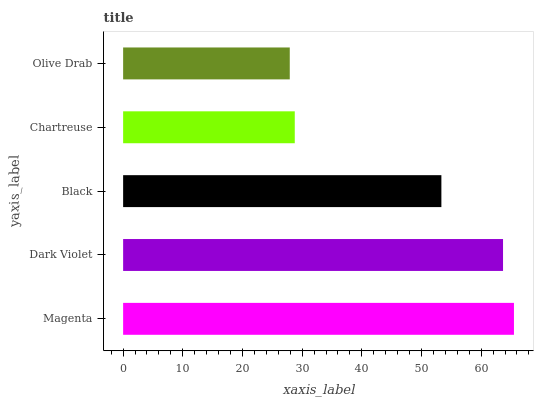Is Olive Drab the minimum?
Answer yes or no. Yes. Is Magenta the maximum?
Answer yes or no. Yes. Is Dark Violet the minimum?
Answer yes or no. No. Is Dark Violet the maximum?
Answer yes or no. No. Is Magenta greater than Dark Violet?
Answer yes or no. Yes. Is Dark Violet less than Magenta?
Answer yes or no. Yes. Is Dark Violet greater than Magenta?
Answer yes or no. No. Is Magenta less than Dark Violet?
Answer yes or no. No. Is Black the high median?
Answer yes or no. Yes. Is Black the low median?
Answer yes or no. Yes. Is Dark Violet the high median?
Answer yes or no. No. Is Magenta the low median?
Answer yes or no. No. 